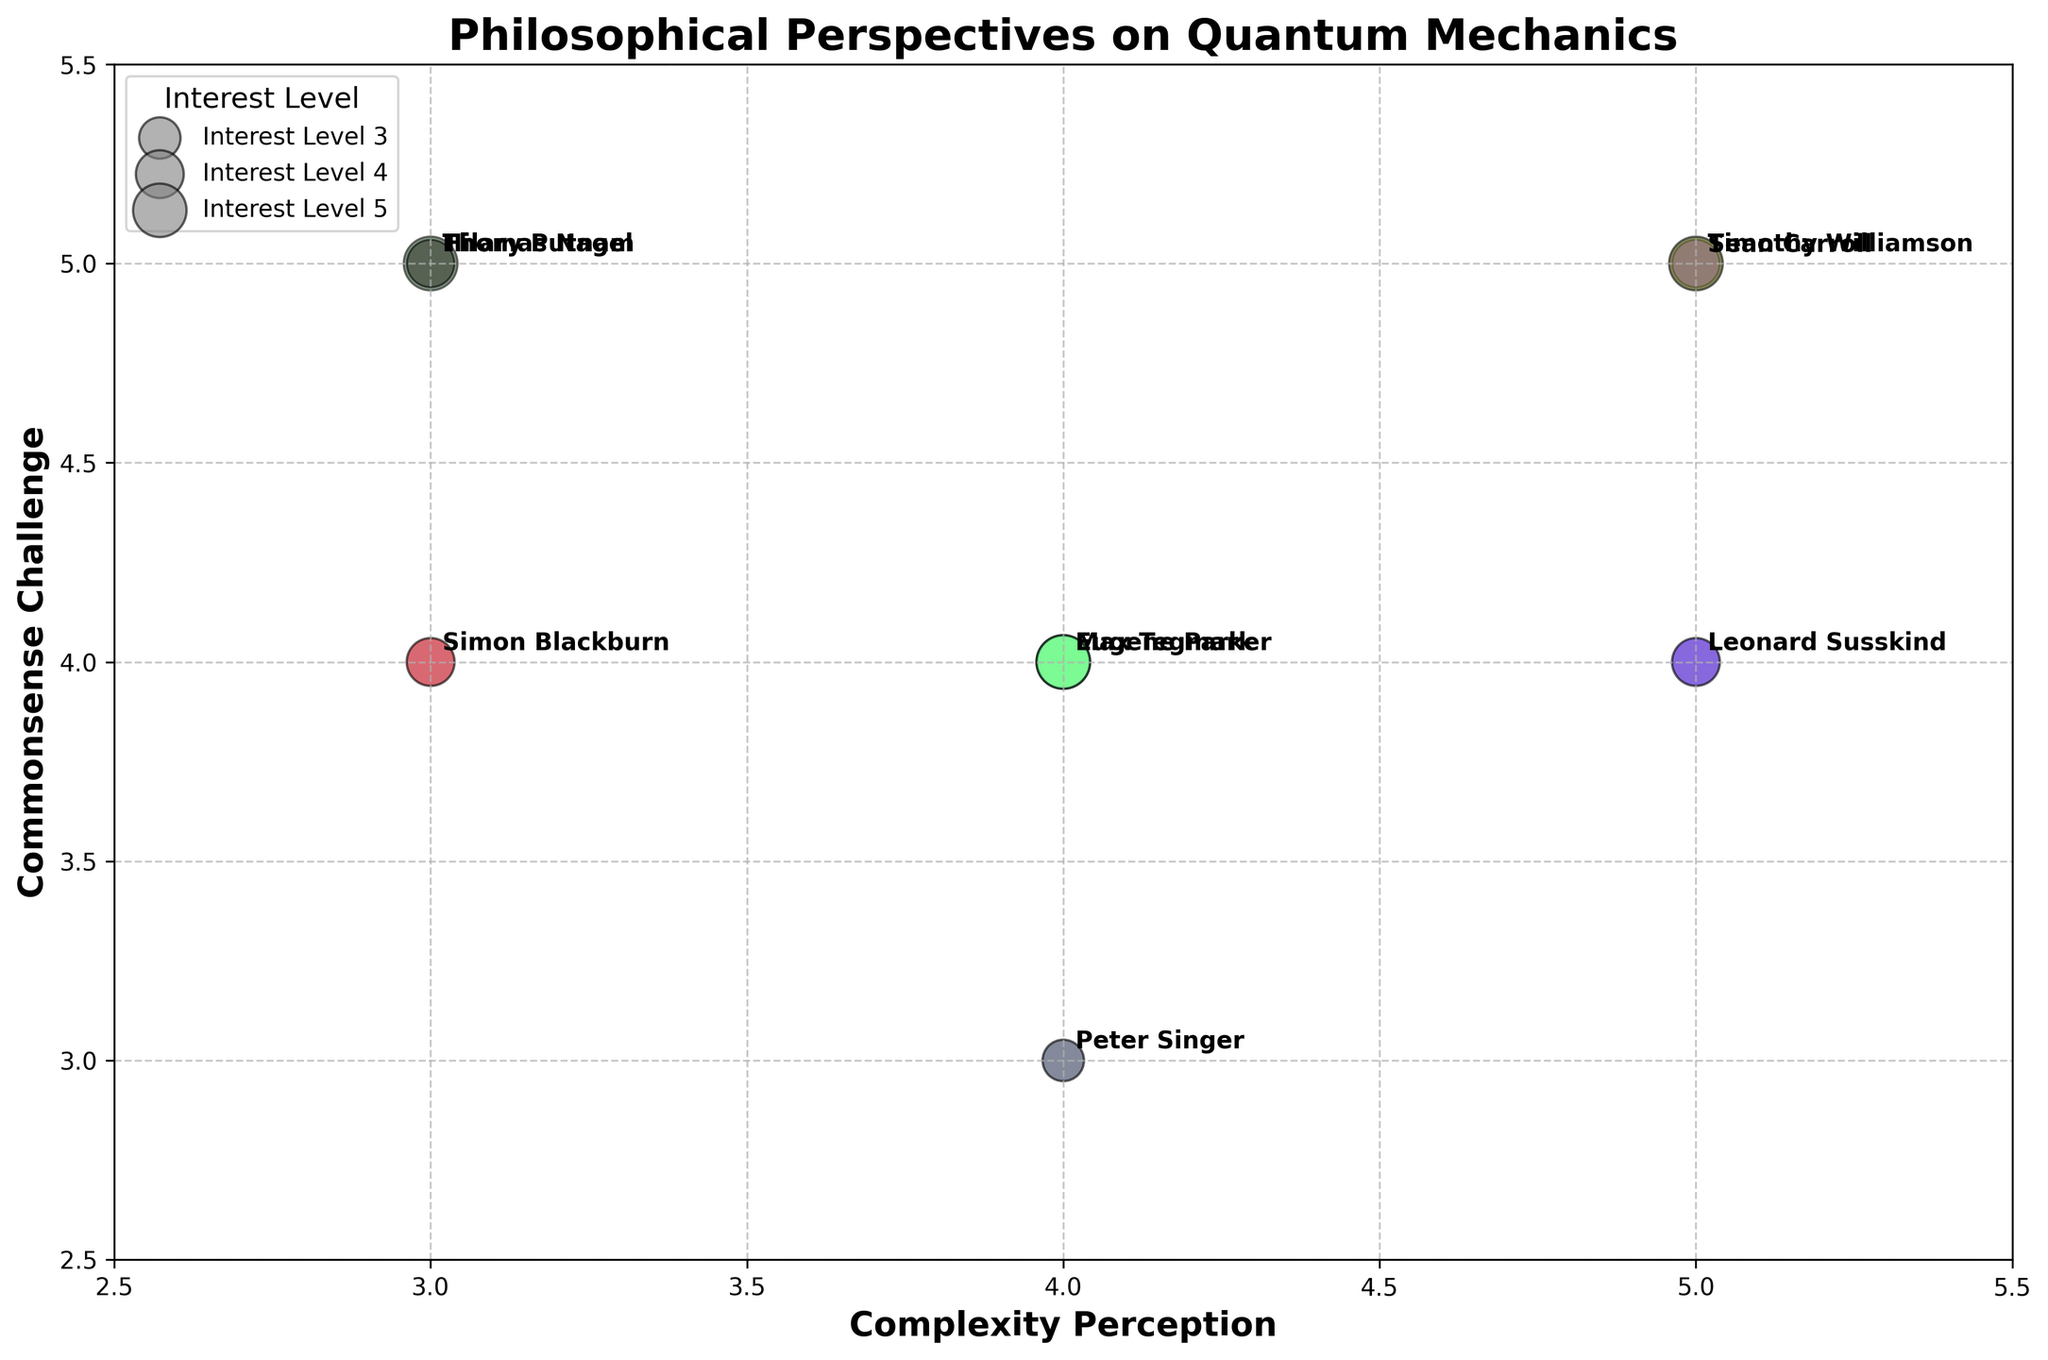What is the title of the figure? The title is usually bold and prominently placed at the top of the chart. In this figure, it reads 'Philosophical Perspectives on Quantum Mechanics', as indicated in the code.
Answer: Philosophical Perspectives on Quantum Mechanics Which axis represents 'Complexity Perception'? The axes are labeled clearly, with the x-axis representing 'Complexity Perception' as evident from the code labeling. This is located along the horizontal axis.
Answer: x-axis How many disciplines are represented in the figure? Each bubble represents a specific philosopher or physicist, and the discipline can be inferred from color or label. The disciplines listed are Philosophy and Physics. Counting the two unique disciplines gives us the answer.
Answer: 2 Which philosopher is associated with the highest 'Commonsense Challenge' value? Locate the philosopher names along the y-axis at the highest point, which should be a value of 5. Several philosophers have a 'Commonsense Challenge' value of 5. Double-checking these, Timothy Williamson stands out as a philosopher.
Answer: Timothy Williamson How does 'Interest Level' affect the size of the bubbles? The 'Interest Level' determines the size of the bubbles, with higher interest levels corresponding to larger bubble sizes. Bubbles with larger sizes indicate higher 'Interest Level' values.
Answer: Higher interest level, larger size Which philosopher or physicist has the smallest bubble size, and what is their 'Interest Level'? Small bubbles correspond to lower 'Interest Level'. By examining the bubbles, Peter Singer from Princeton University with a smaller bubble size has an 'Interest Level' of 3.
Answer: Peter Singer, Interest Level 3 Compare the bubbles of Max Tegmark and Hilary Putnam. Which has a higher 'Complexity Perception' score? Max Tegmark and Hilary Putnam can be located and compared on the x-axis. Max Tegmark has a 'Complexity Perception' of 4, while Hilary Putnam has a score of 3. Thus, Max Tegmark's score is higher.
Answer: Max Tegmark Who among the philosophers challenges common sense the most but perceives complexity at a moderate level? Identifying philosophers with a 'Commonsense Challenge' of 5 and a moderate 'Complexity Perception' of around 4, Thomas Nagel fits the criteria with a 4 for 'Complexity Perception'.
Answer: Thomas Nagel If you average the 'Complexity Perception' of the physicists, what would it be? The 'Complexity Perception' values for physicists are 4 (Max Tegmark), 5 (Sean Carroll), 4 (Leonard Susskind), and 4 (Eugene Parker). Summing these (4 + 5 + 4 + 4) = 17 and dividing by the number of physicists (4) gives an average of 4.25.
Answer: 4.25 Which academic from the University of Cambridge has a 'Complexity Perception' score of 3 and how does it compare with their 'Commonsense Challenge' score? Locate the academic from the University of Cambridge, which is Simon Blackburn. His 'Complexity Perception' is 3 and 'Commonsense Challenge' is 4, indicating he rates commonsense challenge higher than complexity.
Answer: Simon Blackburn, higher Commonsense Challenge 